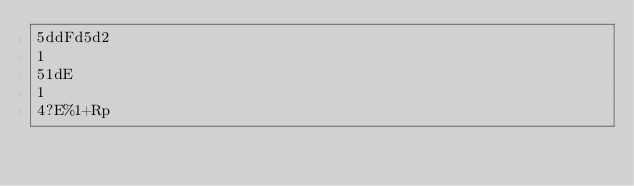Convert code to text. <code><loc_0><loc_0><loc_500><loc_500><_dc_>5ddFd5d2
1
51dE
1
4?E%1+Rp</code> 